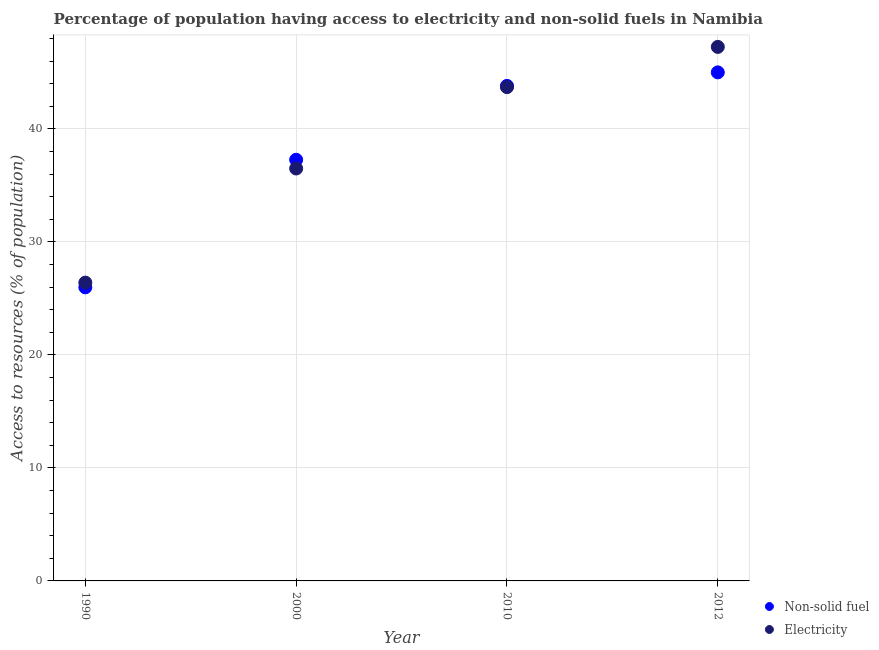What is the percentage of population having access to electricity in 2010?
Your answer should be compact. 43.7. Across all years, what is the maximum percentage of population having access to electricity?
Give a very brief answer. 47.26. Across all years, what is the minimum percentage of population having access to electricity?
Make the answer very short. 26.4. In which year was the percentage of population having access to non-solid fuel minimum?
Give a very brief answer. 1990. What is the total percentage of population having access to non-solid fuel in the graph?
Make the answer very short. 152.08. What is the difference between the percentage of population having access to non-solid fuel in 1990 and that in 2012?
Your response must be concise. -19.02. What is the difference between the percentage of population having access to non-solid fuel in 1990 and the percentage of population having access to electricity in 2012?
Make the answer very short. -21.28. What is the average percentage of population having access to non-solid fuel per year?
Make the answer very short. 38.02. In the year 2012, what is the difference between the percentage of population having access to electricity and percentage of population having access to non-solid fuel?
Keep it short and to the point. 2.25. In how many years, is the percentage of population having access to non-solid fuel greater than 32 %?
Provide a succinct answer. 3. What is the ratio of the percentage of population having access to non-solid fuel in 2000 to that in 2012?
Make the answer very short. 0.83. Is the percentage of population having access to non-solid fuel in 2000 less than that in 2012?
Provide a succinct answer. Yes. What is the difference between the highest and the second highest percentage of population having access to non-solid fuel?
Give a very brief answer. 1.2. What is the difference between the highest and the lowest percentage of population having access to electricity?
Make the answer very short. 20.86. In how many years, is the percentage of population having access to non-solid fuel greater than the average percentage of population having access to non-solid fuel taken over all years?
Offer a terse response. 2. Does the percentage of population having access to non-solid fuel monotonically increase over the years?
Your answer should be very brief. Yes. Is the percentage of population having access to electricity strictly greater than the percentage of population having access to non-solid fuel over the years?
Give a very brief answer. No. How many dotlines are there?
Provide a succinct answer. 2. How many years are there in the graph?
Give a very brief answer. 4. Are the values on the major ticks of Y-axis written in scientific E-notation?
Your answer should be very brief. No. Does the graph contain any zero values?
Make the answer very short. No. What is the title of the graph?
Offer a terse response. Percentage of population having access to electricity and non-solid fuels in Namibia. Does "Residents" appear as one of the legend labels in the graph?
Keep it short and to the point. No. What is the label or title of the Y-axis?
Ensure brevity in your answer.  Access to resources (% of population). What is the Access to resources (% of population) in Non-solid fuel in 1990?
Ensure brevity in your answer.  25.98. What is the Access to resources (% of population) in Electricity in 1990?
Provide a short and direct response. 26.4. What is the Access to resources (% of population) of Non-solid fuel in 2000?
Give a very brief answer. 37.27. What is the Access to resources (% of population) in Electricity in 2000?
Provide a succinct answer. 36.5. What is the Access to resources (% of population) in Non-solid fuel in 2010?
Make the answer very short. 43.81. What is the Access to resources (% of population) in Electricity in 2010?
Provide a succinct answer. 43.7. What is the Access to resources (% of population) in Non-solid fuel in 2012?
Keep it short and to the point. 45.01. What is the Access to resources (% of population) of Electricity in 2012?
Your answer should be compact. 47.26. Across all years, what is the maximum Access to resources (% of population) of Non-solid fuel?
Keep it short and to the point. 45.01. Across all years, what is the maximum Access to resources (% of population) of Electricity?
Keep it short and to the point. 47.26. Across all years, what is the minimum Access to resources (% of population) of Non-solid fuel?
Make the answer very short. 25.98. Across all years, what is the minimum Access to resources (% of population) in Electricity?
Keep it short and to the point. 26.4. What is the total Access to resources (% of population) in Non-solid fuel in the graph?
Offer a very short reply. 152.08. What is the total Access to resources (% of population) in Electricity in the graph?
Your response must be concise. 153.86. What is the difference between the Access to resources (% of population) of Non-solid fuel in 1990 and that in 2000?
Give a very brief answer. -11.29. What is the difference between the Access to resources (% of population) of Electricity in 1990 and that in 2000?
Keep it short and to the point. -10.1. What is the difference between the Access to resources (% of population) of Non-solid fuel in 1990 and that in 2010?
Offer a terse response. -17.83. What is the difference between the Access to resources (% of population) in Electricity in 1990 and that in 2010?
Give a very brief answer. -17.3. What is the difference between the Access to resources (% of population) of Non-solid fuel in 1990 and that in 2012?
Give a very brief answer. -19.02. What is the difference between the Access to resources (% of population) of Electricity in 1990 and that in 2012?
Give a very brief answer. -20.86. What is the difference between the Access to resources (% of population) of Non-solid fuel in 2000 and that in 2010?
Offer a very short reply. -6.54. What is the difference between the Access to resources (% of population) of Non-solid fuel in 2000 and that in 2012?
Provide a short and direct response. -7.73. What is the difference between the Access to resources (% of population) of Electricity in 2000 and that in 2012?
Give a very brief answer. -10.76. What is the difference between the Access to resources (% of population) in Non-solid fuel in 2010 and that in 2012?
Provide a succinct answer. -1.2. What is the difference between the Access to resources (% of population) in Electricity in 2010 and that in 2012?
Provide a succinct answer. -3.56. What is the difference between the Access to resources (% of population) of Non-solid fuel in 1990 and the Access to resources (% of population) of Electricity in 2000?
Your answer should be very brief. -10.52. What is the difference between the Access to resources (% of population) in Non-solid fuel in 1990 and the Access to resources (% of population) in Electricity in 2010?
Provide a short and direct response. -17.72. What is the difference between the Access to resources (% of population) of Non-solid fuel in 1990 and the Access to resources (% of population) of Electricity in 2012?
Your answer should be compact. -21.28. What is the difference between the Access to resources (% of population) in Non-solid fuel in 2000 and the Access to resources (% of population) in Electricity in 2010?
Your response must be concise. -6.43. What is the difference between the Access to resources (% of population) of Non-solid fuel in 2000 and the Access to resources (% of population) of Electricity in 2012?
Provide a succinct answer. -9.99. What is the difference between the Access to resources (% of population) of Non-solid fuel in 2010 and the Access to resources (% of population) of Electricity in 2012?
Your answer should be compact. -3.45. What is the average Access to resources (% of population) of Non-solid fuel per year?
Your answer should be very brief. 38.02. What is the average Access to resources (% of population) of Electricity per year?
Offer a terse response. 38.47. In the year 1990, what is the difference between the Access to resources (% of population) in Non-solid fuel and Access to resources (% of population) in Electricity?
Your answer should be very brief. -0.42. In the year 2000, what is the difference between the Access to resources (% of population) of Non-solid fuel and Access to resources (% of population) of Electricity?
Your answer should be compact. 0.77. In the year 2010, what is the difference between the Access to resources (% of population) in Non-solid fuel and Access to resources (% of population) in Electricity?
Ensure brevity in your answer.  0.11. In the year 2012, what is the difference between the Access to resources (% of population) in Non-solid fuel and Access to resources (% of population) in Electricity?
Ensure brevity in your answer.  -2.25. What is the ratio of the Access to resources (% of population) in Non-solid fuel in 1990 to that in 2000?
Your answer should be very brief. 0.7. What is the ratio of the Access to resources (% of population) of Electricity in 1990 to that in 2000?
Provide a succinct answer. 0.72. What is the ratio of the Access to resources (% of population) in Non-solid fuel in 1990 to that in 2010?
Offer a terse response. 0.59. What is the ratio of the Access to resources (% of population) of Electricity in 1990 to that in 2010?
Ensure brevity in your answer.  0.6. What is the ratio of the Access to resources (% of population) in Non-solid fuel in 1990 to that in 2012?
Keep it short and to the point. 0.58. What is the ratio of the Access to resources (% of population) of Electricity in 1990 to that in 2012?
Your answer should be compact. 0.56. What is the ratio of the Access to resources (% of population) in Non-solid fuel in 2000 to that in 2010?
Keep it short and to the point. 0.85. What is the ratio of the Access to resources (% of population) in Electricity in 2000 to that in 2010?
Your answer should be compact. 0.84. What is the ratio of the Access to resources (% of population) in Non-solid fuel in 2000 to that in 2012?
Give a very brief answer. 0.83. What is the ratio of the Access to resources (% of population) of Electricity in 2000 to that in 2012?
Keep it short and to the point. 0.77. What is the ratio of the Access to resources (% of population) in Non-solid fuel in 2010 to that in 2012?
Provide a succinct answer. 0.97. What is the ratio of the Access to resources (% of population) in Electricity in 2010 to that in 2012?
Offer a very short reply. 0.92. What is the difference between the highest and the second highest Access to resources (% of population) in Non-solid fuel?
Keep it short and to the point. 1.2. What is the difference between the highest and the second highest Access to resources (% of population) in Electricity?
Give a very brief answer. 3.56. What is the difference between the highest and the lowest Access to resources (% of population) of Non-solid fuel?
Make the answer very short. 19.02. What is the difference between the highest and the lowest Access to resources (% of population) of Electricity?
Your answer should be very brief. 20.86. 